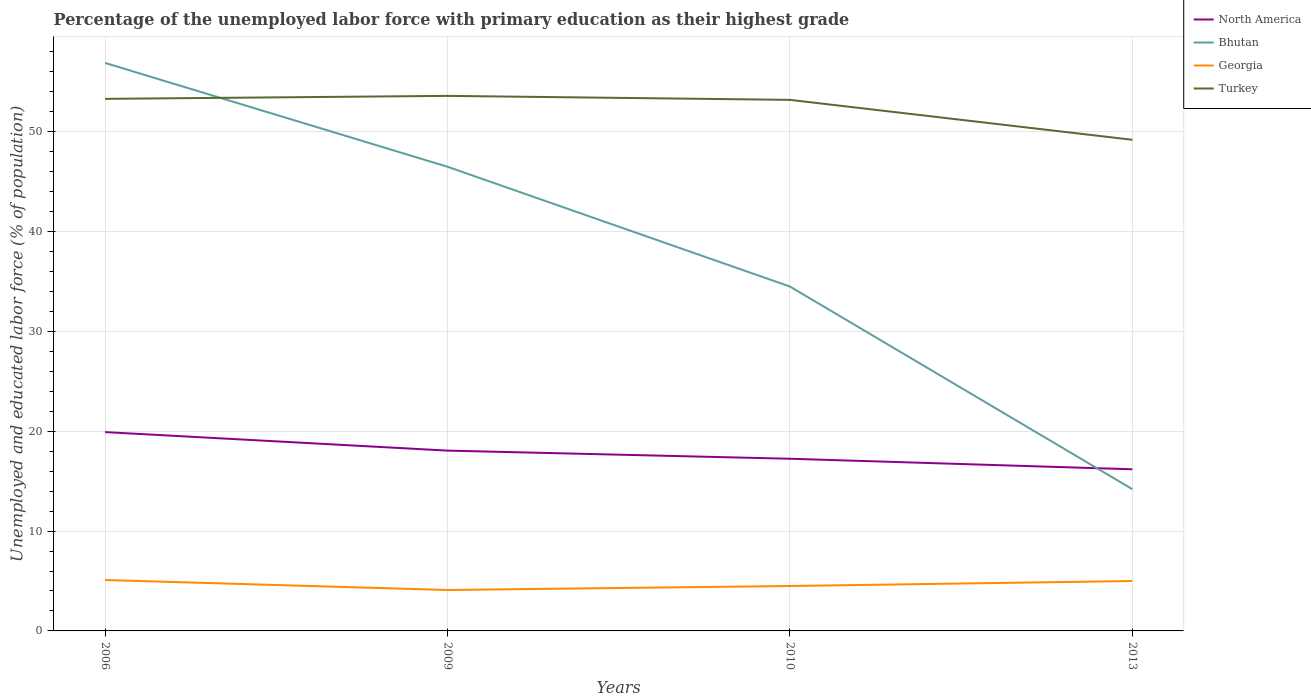Is the number of lines equal to the number of legend labels?
Offer a very short reply. Yes. Across all years, what is the maximum percentage of the unemployed labor force with primary education in Turkey?
Keep it short and to the point. 49.2. What is the total percentage of the unemployed labor force with primary education in Bhutan in the graph?
Keep it short and to the point. 20.3. What is the difference between the highest and the second highest percentage of the unemployed labor force with primary education in North America?
Keep it short and to the point. 3.73. Is the percentage of the unemployed labor force with primary education in North America strictly greater than the percentage of the unemployed labor force with primary education in Turkey over the years?
Provide a short and direct response. Yes. How many lines are there?
Your answer should be very brief. 4. What is the difference between two consecutive major ticks on the Y-axis?
Your response must be concise. 10. Are the values on the major ticks of Y-axis written in scientific E-notation?
Make the answer very short. No. Does the graph contain any zero values?
Provide a succinct answer. No. How many legend labels are there?
Offer a terse response. 4. What is the title of the graph?
Ensure brevity in your answer.  Percentage of the unemployed labor force with primary education as their highest grade. What is the label or title of the X-axis?
Your answer should be compact. Years. What is the label or title of the Y-axis?
Keep it short and to the point. Unemployed and educated labor force (% of population). What is the Unemployed and educated labor force (% of population) of North America in 2006?
Provide a short and direct response. 19.92. What is the Unemployed and educated labor force (% of population) in Bhutan in 2006?
Provide a succinct answer. 56.9. What is the Unemployed and educated labor force (% of population) of Georgia in 2006?
Your answer should be very brief. 5.1. What is the Unemployed and educated labor force (% of population) in Turkey in 2006?
Keep it short and to the point. 53.3. What is the Unemployed and educated labor force (% of population) in North America in 2009?
Your response must be concise. 18.06. What is the Unemployed and educated labor force (% of population) of Bhutan in 2009?
Offer a terse response. 46.5. What is the Unemployed and educated labor force (% of population) of Georgia in 2009?
Your answer should be compact. 4.1. What is the Unemployed and educated labor force (% of population) in Turkey in 2009?
Your answer should be compact. 53.6. What is the Unemployed and educated labor force (% of population) in North America in 2010?
Ensure brevity in your answer.  17.25. What is the Unemployed and educated labor force (% of population) of Bhutan in 2010?
Your response must be concise. 34.5. What is the Unemployed and educated labor force (% of population) in Turkey in 2010?
Your response must be concise. 53.2. What is the Unemployed and educated labor force (% of population) in North America in 2013?
Ensure brevity in your answer.  16.19. What is the Unemployed and educated labor force (% of population) in Bhutan in 2013?
Your response must be concise. 14.2. What is the Unemployed and educated labor force (% of population) of Turkey in 2013?
Offer a terse response. 49.2. Across all years, what is the maximum Unemployed and educated labor force (% of population) in North America?
Your answer should be very brief. 19.92. Across all years, what is the maximum Unemployed and educated labor force (% of population) of Bhutan?
Make the answer very short. 56.9. Across all years, what is the maximum Unemployed and educated labor force (% of population) in Georgia?
Your response must be concise. 5.1. Across all years, what is the maximum Unemployed and educated labor force (% of population) of Turkey?
Keep it short and to the point. 53.6. Across all years, what is the minimum Unemployed and educated labor force (% of population) in North America?
Offer a terse response. 16.19. Across all years, what is the minimum Unemployed and educated labor force (% of population) in Bhutan?
Your answer should be very brief. 14.2. Across all years, what is the minimum Unemployed and educated labor force (% of population) of Georgia?
Ensure brevity in your answer.  4.1. Across all years, what is the minimum Unemployed and educated labor force (% of population) in Turkey?
Your answer should be very brief. 49.2. What is the total Unemployed and educated labor force (% of population) in North America in the graph?
Offer a very short reply. 71.42. What is the total Unemployed and educated labor force (% of population) of Bhutan in the graph?
Ensure brevity in your answer.  152.1. What is the total Unemployed and educated labor force (% of population) of Turkey in the graph?
Make the answer very short. 209.3. What is the difference between the Unemployed and educated labor force (% of population) in North America in 2006 and that in 2009?
Your answer should be compact. 1.85. What is the difference between the Unemployed and educated labor force (% of population) of Bhutan in 2006 and that in 2009?
Keep it short and to the point. 10.4. What is the difference between the Unemployed and educated labor force (% of population) of Turkey in 2006 and that in 2009?
Your answer should be compact. -0.3. What is the difference between the Unemployed and educated labor force (% of population) of North America in 2006 and that in 2010?
Your answer should be compact. 2.67. What is the difference between the Unemployed and educated labor force (% of population) in Bhutan in 2006 and that in 2010?
Provide a short and direct response. 22.4. What is the difference between the Unemployed and educated labor force (% of population) in Georgia in 2006 and that in 2010?
Your answer should be compact. 0.6. What is the difference between the Unemployed and educated labor force (% of population) of Turkey in 2006 and that in 2010?
Keep it short and to the point. 0.1. What is the difference between the Unemployed and educated labor force (% of population) of North America in 2006 and that in 2013?
Make the answer very short. 3.73. What is the difference between the Unemployed and educated labor force (% of population) in Bhutan in 2006 and that in 2013?
Ensure brevity in your answer.  42.7. What is the difference between the Unemployed and educated labor force (% of population) in North America in 2009 and that in 2010?
Provide a short and direct response. 0.81. What is the difference between the Unemployed and educated labor force (% of population) of Turkey in 2009 and that in 2010?
Offer a very short reply. 0.4. What is the difference between the Unemployed and educated labor force (% of population) in North America in 2009 and that in 2013?
Ensure brevity in your answer.  1.87. What is the difference between the Unemployed and educated labor force (% of population) of Bhutan in 2009 and that in 2013?
Offer a terse response. 32.3. What is the difference between the Unemployed and educated labor force (% of population) in Turkey in 2009 and that in 2013?
Your answer should be very brief. 4.4. What is the difference between the Unemployed and educated labor force (% of population) of North America in 2010 and that in 2013?
Offer a terse response. 1.06. What is the difference between the Unemployed and educated labor force (% of population) of Bhutan in 2010 and that in 2013?
Offer a terse response. 20.3. What is the difference between the Unemployed and educated labor force (% of population) of Georgia in 2010 and that in 2013?
Provide a short and direct response. -0.5. What is the difference between the Unemployed and educated labor force (% of population) in North America in 2006 and the Unemployed and educated labor force (% of population) in Bhutan in 2009?
Your answer should be very brief. -26.58. What is the difference between the Unemployed and educated labor force (% of population) in North America in 2006 and the Unemployed and educated labor force (% of population) in Georgia in 2009?
Your answer should be very brief. 15.82. What is the difference between the Unemployed and educated labor force (% of population) in North America in 2006 and the Unemployed and educated labor force (% of population) in Turkey in 2009?
Make the answer very short. -33.68. What is the difference between the Unemployed and educated labor force (% of population) of Bhutan in 2006 and the Unemployed and educated labor force (% of population) of Georgia in 2009?
Offer a terse response. 52.8. What is the difference between the Unemployed and educated labor force (% of population) of Georgia in 2006 and the Unemployed and educated labor force (% of population) of Turkey in 2009?
Offer a very short reply. -48.5. What is the difference between the Unemployed and educated labor force (% of population) in North America in 2006 and the Unemployed and educated labor force (% of population) in Bhutan in 2010?
Give a very brief answer. -14.58. What is the difference between the Unemployed and educated labor force (% of population) in North America in 2006 and the Unemployed and educated labor force (% of population) in Georgia in 2010?
Your response must be concise. 15.42. What is the difference between the Unemployed and educated labor force (% of population) in North America in 2006 and the Unemployed and educated labor force (% of population) in Turkey in 2010?
Give a very brief answer. -33.28. What is the difference between the Unemployed and educated labor force (% of population) in Bhutan in 2006 and the Unemployed and educated labor force (% of population) in Georgia in 2010?
Provide a succinct answer. 52.4. What is the difference between the Unemployed and educated labor force (% of population) in Georgia in 2006 and the Unemployed and educated labor force (% of population) in Turkey in 2010?
Ensure brevity in your answer.  -48.1. What is the difference between the Unemployed and educated labor force (% of population) in North America in 2006 and the Unemployed and educated labor force (% of population) in Bhutan in 2013?
Offer a very short reply. 5.72. What is the difference between the Unemployed and educated labor force (% of population) of North America in 2006 and the Unemployed and educated labor force (% of population) of Georgia in 2013?
Offer a very short reply. 14.92. What is the difference between the Unemployed and educated labor force (% of population) of North America in 2006 and the Unemployed and educated labor force (% of population) of Turkey in 2013?
Provide a short and direct response. -29.28. What is the difference between the Unemployed and educated labor force (% of population) of Bhutan in 2006 and the Unemployed and educated labor force (% of population) of Georgia in 2013?
Offer a terse response. 51.9. What is the difference between the Unemployed and educated labor force (% of population) of Georgia in 2006 and the Unemployed and educated labor force (% of population) of Turkey in 2013?
Provide a succinct answer. -44.1. What is the difference between the Unemployed and educated labor force (% of population) of North America in 2009 and the Unemployed and educated labor force (% of population) of Bhutan in 2010?
Your answer should be compact. -16.44. What is the difference between the Unemployed and educated labor force (% of population) in North America in 2009 and the Unemployed and educated labor force (% of population) in Georgia in 2010?
Provide a short and direct response. 13.56. What is the difference between the Unemployed and educated labor force (% of population) of North America in 2009 and the Unemployed and educated labor force (% of population) of Turkey in 2010?
Offer a very short reply. -35.14. What is the difference between the Unemployed and educated labor force (% of population) of Georgia in 2009 and the Unemployed and educated labor force (% of population) of Turkey in 2010?
Offer a terse response. -49.1. What is the difference between the Unemployed and educated labor force (% of population) of North America in 2009 and the Unemployed and educated labor force (% of population) of Bhutan in 2013?
Your answer should be compact. 3.86. What is the difference between the Unemployed and educated labor force (% of population) of North America in 2009 and the Unemployed and educated labor force (% of population) of Georgia in 2013?
Ensure brevity in your answer.  13.06. What is the difference between the Unemployed and educated labor force (% of population) of North America in 2009 and the Unemployed and educated labor force (% of population) of Turkey in 2013?
Give a very brief answer. -31.14. What is the difference between the Unemployed and educated labor force (% of population) in Bhutan in 2009 and the Unemployed and educated labor force (% of population) in Georgia in 2013?
Keep it short and to the point. 41.5. What is the difference between the Unemployed and educated labor force (% of population) of Bhutan in 2009 and the Unemployed and educated labor force (% of population) of Turkey in 2013?
Provide a succinct answer. -2.7. What is the difference between the Unemployed and educated labor force (% of population) of Georgia in 2009 and the Unemployed and educated labor force (% of population) of Turkey in 2013?
Give a very brief answer. -45.1. What is the difference between the Unemployed and educated labor force (% of population) of North America in 2010 and the Unemployed and educated labor force (% of population) of Bhutan in 2013?
Give a very brief answer. 3.05. What is the difference between the Unemployed and educated labor force (% of population) of North America in 2010 and the Unemployed and educated labor force (% of population) of Georgia in 2013?
Make the answer very short. 12.25. What is the difference between the Unemployed and educated labor force (% of population) in North America in 2010 and the Unemployed and educated labor force (% of population) in Turkey in 2013?
Your answer should be compact. -31.95. What is the difference between the Unemployed and educated labor force (% of population) of Bhutan in 2010 and the Unemployed and educated labor force (% of population) of Georgia in 2013?
Give a very brief answer. 29.5. What is the difference between the Unemployed and educated labor force (% of population) of Bhutan in 2010 and the Unemployed and educated labor force (% of population) of Turkey in 2013?
Your answer should be compact. -14.7. What is the difference between the Unemployed and educated labor force (% of population) in Georgia in 2010 and the Unemployed and educated labor force (% of population) in Turkey in 2013?
Offer a terse response. -44.7. What is the average Unemployed and educated labor force (% of population) in North America per year?
Offer a very short reply. 17.86. What is the average Unemployed and educated labor force (% of population) of Bhutan per year?
Keep it short and to the point. 38.02. What is the average Unemployed and educated labor force (% of population) of Georgia per year?
Provide a short and direct response. 4.67. What is the average Unemployed and educated labor force (% of population) of Turkey per year?
Your answer should be compact. 52.33. In the year 2006, what is the difference between the Unemployed and educated labor force (% of population) of North America and Unemployed and educated labor force (% of population) of Bhutan?
Give a very brief answer. -36.98. In the year 2006, what is the difference between the Unemployed and educated labor force (% of population) of North America and Unemployed and educated labor force (% of population) of Georgia?
Provide a succinct answer. 14.82. In the year 2006, what is the difference between the Unemployed and educated labor force (% of population) of North America and Unemployed and educated labor force (% of population) of Turkey?
Your answer should be compact. -33.38. In the year 2006, what is the difference between the Unemployed and educated labor force (% of population) in Bhutan and Unemployed and educated labor force (% of population) in Georgia?
Provide a short and direct response. 51.8. In the year 2006, what is the difference between the Unemployed and educated labor force (% of population) of Georgia and Unemployed and educated labor force (% of population) of Turkey?
Provide a short and direct response. -48.2. In the year 2009, what is the difference between the Unemployed and educated labor force (% of population) in North America and Unemployed and educated labor force (% of population) in Bhutan?
Your response must be concise. -28.44. In the year 2009, what is the difference between the Unemployed and educated labor force (% of population) in North America and Unemployed and educated labor force (% of population) in Georgia?
Make the answer very short. 13.96. In the year 2009, what is the difference between the Unemployed and educated labor force (% of population) of North America and Unemployed and educated labor force (% of population) of Turkey?
Make the answer very short. -35.54. In the year 2009, what is the difference between the Unemployed and educated labor force (% of population) in Bhutan and Unemployed and educated labor force (% of population) in Georgia?
Offer a very short reply. 42.4. In the year 2009, what is the difference between the Unemployed and educated labor force (% of population) in Bhutan and Unemployed and educated labor force (% of population) in Turkey?
Your response must be concise. -7.1. In the year 2009, what is the difference between the Unemployed and educated labor force (% of population) of Georgia and Unemployed and educated labor force (% of population) of Turkey?
Your response must be concise. -49.5. In the year 2010, what is the difference between the Unemployed and educated labor force (% of population) of North America and Unemployed and educated labor force (% of population) of Bhutan?
Keep it short and to the point. -17.25. In the year 2010, what is the difference between the Unemployed and educated labor force (% of population) of North America and Unemployed and educated labor force (% of population) of Georgia?
Keep it short and to the point. 12.75. In the year 2010, what is the difference between the Unemployed and educated labor force (% of population) in North America and Unemployed and educated labor force (% of population) in Turkey?
Ensure brevity in your answer.  -35.95. In the year 2010, what is the difference between the Unemployed and educated labor force (% of population) of Bhutan and Unemployed and educated labor force (% of population) of Turkey?
Offer a terse response. -18.7. In the year 2010, what is the difference between the Unemployed and educated labor force (% of population) in Georgia and Unemployed and educated labor force (% of population) in Turkey?
Ensure brevity in your answer.  -48.7. In the year 2013, what is the difference between the Unemployed and educated labor force (% of population) in North America and Unemployed and educated labor force (% of population) in Bhutan?
Keep it short and to the point. 1.99. In the year 2013, what is the difference between the Unemployed and educated labor force (% of population) of North America and Unemployed and educated labor force (% of population) of Georgia?
Offer a very short reply. 11.19. In the year 2013, what is the difference between the Unemployed and educated labor force (% of population) in North America and Unemployed and educated labor force (% of population) in Turkey?
Your answer should be very brief. -33.01. In the year 2013, what is the difference between the Unemployed and educated labor force (% of population) of Bhutan and Unemployed and educated labor force (% of population) of Turkey?
Provide a short and direct response. -35. In the year 2013, what is the difference between the Unemployed and educated labor force (% of population) of Georgia and Unemployed and educated labor force (% of population) of Turkey?
Your response must be concise. -44.2. What is the ratio of the Unemployed and educated labor force (% of population) in North America in 2006 to that in 2009?
Offer a very short reply. 1.1. What is the ratio of the Unemployed and educated labor force (% of population) of Bhutan in 2006 to that in 2009?
Your response must be concise. 1.22. What is the ratio of the Unemployed and educated labor force (% of population) in Georgia in 2006 to that in 2009?
Offer a terse response. 1.24. What is the ratio of the Unemployed and educated labor force (% of population) of Turkey in 2006 to that in 2009?
Your answer should be very brief. 0.99. What is the ratio of the Unemployed and educated labor force (% of population) of North America in 2006 to that in 2010?
Make the answer very short. 1.15. What is the ratio of the Unemployed and educated labor force (% of population) of Bhutan in 2006 to that in 2010?
Keep it short and to the point. 1.65. What is the ratio of the Unemployed and educated labor force (% of population) in Georgia in 2006 to that in 2010?
Ensure brevity in your answer.  1.13. What is the ratio of the Unemployed and educated labor force (% of population) of North America in 2006 to that in 2013?
Your response must be concise. 1.23. What is the ratio of the Unemployed and educated labor force (% of population) in Bhutan in 2006 to that in 2013?
Provide a short and direct response. 4.01. What is the ratio of the Unemployed and educated labor force (% of population) in Turkey in 2006 to that in 2013?
Your response must be concise. 1.08. What is the ratio of the Unemployed and educated labor force (% of population) in North America in 2009 to that in 2010?
Provide a short and direct response. 1.05. What is the ratio of the Unemployed and educated labor force (% of population) in Bhutan in 2009 to that in 2010?
Your response must be concise. 1.35. What is the ratio of the Unemployed and educated labor force (% of population) of Georgia in 2009 to that in 2010?
Your answer should be very brief. 0.91. What is the ratio of the Unemployed and educated labor force (% of population) in Turkey in 2009 to that in 2010?
Your answer should be compact. 1.01. What is the ratio of the Unemployed and educated labor force (% of population) in North America in 2009 to that in 2013?
Your answer should be compact. 1.12. What is the ratio of the Unemployed and educated labor force (% of population) in Bhutan in 2009 to that in 2013?
Give a very brief answer. 3.27. What is the ratio of the Unemployed and educated labor force (% of population) of Georgia in 2009 to that in 2013?
Your response must be concise. 0.82. What is the ratio of the Unemployed and educated labor force (% of population) of Turkey in 2009 to that in 2013?
Give a very brief answer. 1.09. What is the ratio of the Unemployed and educated labor force (% of population) of North America in 2010 to that in 2013?
Make the answer very short. 1.07. What is the ratio of the Unemployed and educated labor force (% of population) in Bhutan in 2010 to that in 2013?
Your answer should be compact. 2.43. What is the ratio of the Unemployed and educated labor force (% of population) of Turkey in 2010 to that in 2013?
Your answer should be very brief. 1.08. What is the difference between the highest and the second highest Unemployed and educated labor force (% of population) in North America?
Keep it short and to the point. 1.85. What is the difference between the highest and the second highest Unemployed and educated labor force (% of population) in Bhutan?
Provide a succinct answer. 10.4. What is the difference between the highest and the second highest Unemployed and educated labor force (% of population) in Georgia?
Provide a succinct answer. 0.1. What is the difference between the highest and the lowest Unemployed and educated labor force (% of population) in North America?
Your response must be concise. 3.73. What is the difference between the highest and the lowest Unemployed and educated labor force (% of population) in Bhutan?
Give a very brief answer. 42.7. 